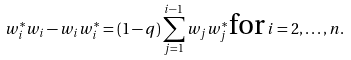Convert formula to latex. <formula><loc_0><loc_0><loc_500><loc_500>w _ { i } ^ { * } w _ { i } - w _ { i } w _ { i } ^ { * } = ( 1 - q ) \sum _ { j = 1 } ^ { i - 1 } w _ { j } w _ { j } ^ { * } \, \text {for} \, i = 2 , \dots , n .</formula> 